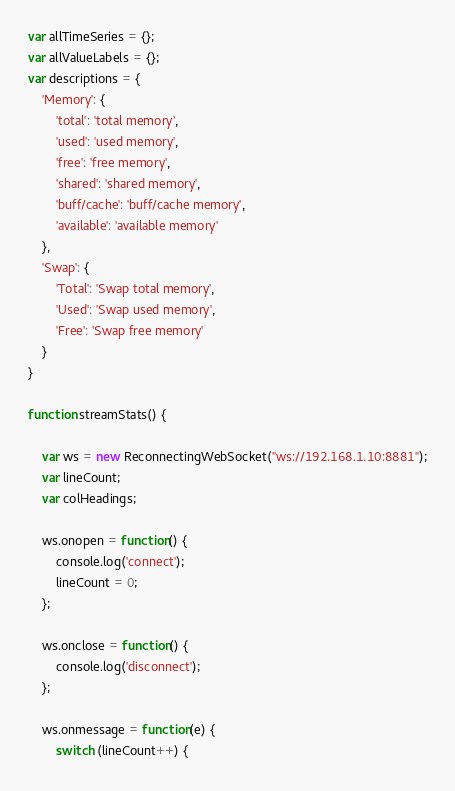<code> <loc_0><loc_0><loc_500><loc_500><_JavaScript_>var allTimeSeries = {};
var allValueLabels = {};
var descriptions = {
    'Memory': {
        'total': 'total memory',
        'used': 'used memory',
        'free': 'free memory',
        'shared': 'shared memory',
        'buff/cache': 'buff/cache memory',
        'available': 'available memory'
    },
    'Swap': {
        'Total': 'Swap total memory',
        'Used': 'Swap used memory',
        'Free': 'Swap free memory'
    }
}

function streamStats() {

    var ws = new ReconnectingWebSocket("ws://192.168.1.10:8881");
    var lineCount;
    var colHeadings;

    ws.onopen = function() {
        console.log('connect');
        lineCount = 0;
    };

    ws.onclose = function() {
        console.log('disconnect');
    };

    ws.onmessage = function(e) {
        switch (lineCount++) {</code> 